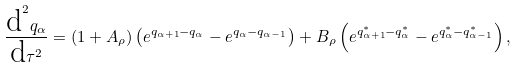Convert formula to latex. <formula><loc_0><loc_0><loc_500><loc_500>\frac { \text {d} ^ { 2 } q _ { \alpha } } { \text {d} \tau ^ { 2 } } = ( 1 + A _ { \rho } ) \left ( e ^ { q _ { \alpha + 1 } - q _ { \alpha } } - e ^ { q _ { \alpha } - q _ { \alpha - 1 } } \right ) + B _ { \rho } \left ( e ^ { q ^ { * } _ { \alpha + 1 } - q ^ { * } _ { \alpha } } - e ^ { q ^ { * } _ { \alpha } - q ^ { * } _ { \alpha - 1 } } \right ) ,</formula> 